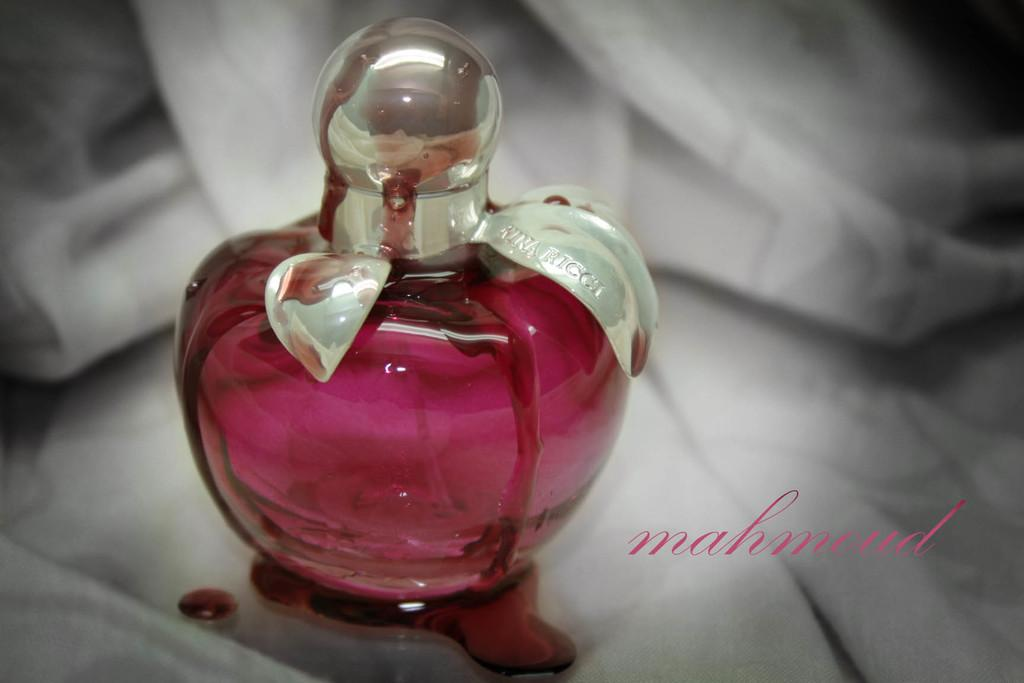<image>
Provide a brief description of the given image. a pink bottle of red liquid named mahmoud 